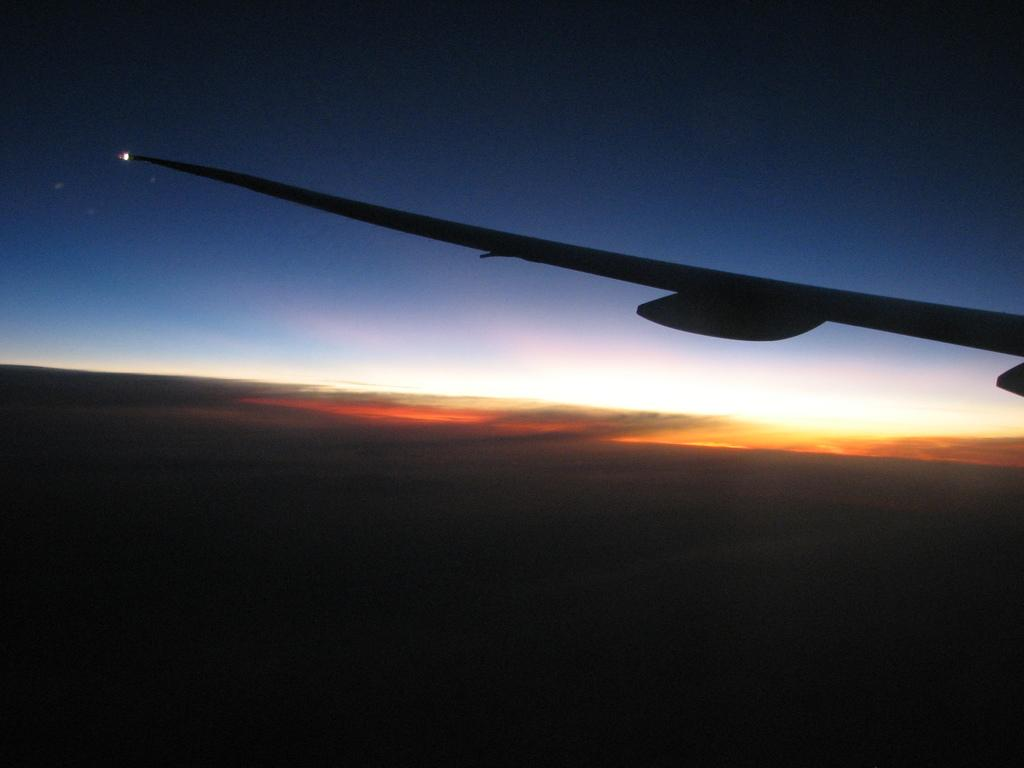What is located on the right side of the image? There is a wing of an airplane on the right side of the image. What can be seen at the top of the image? The sky is visible at the top of the image. How many rats are visible on the wing of the airplane in the image? There are no rats visible on the wing of the airplane in the image. What type of cattle can be seen grazing in the background of the image? There is no background or cattle present in the image; it only features a wing of an airplane and the sky. 